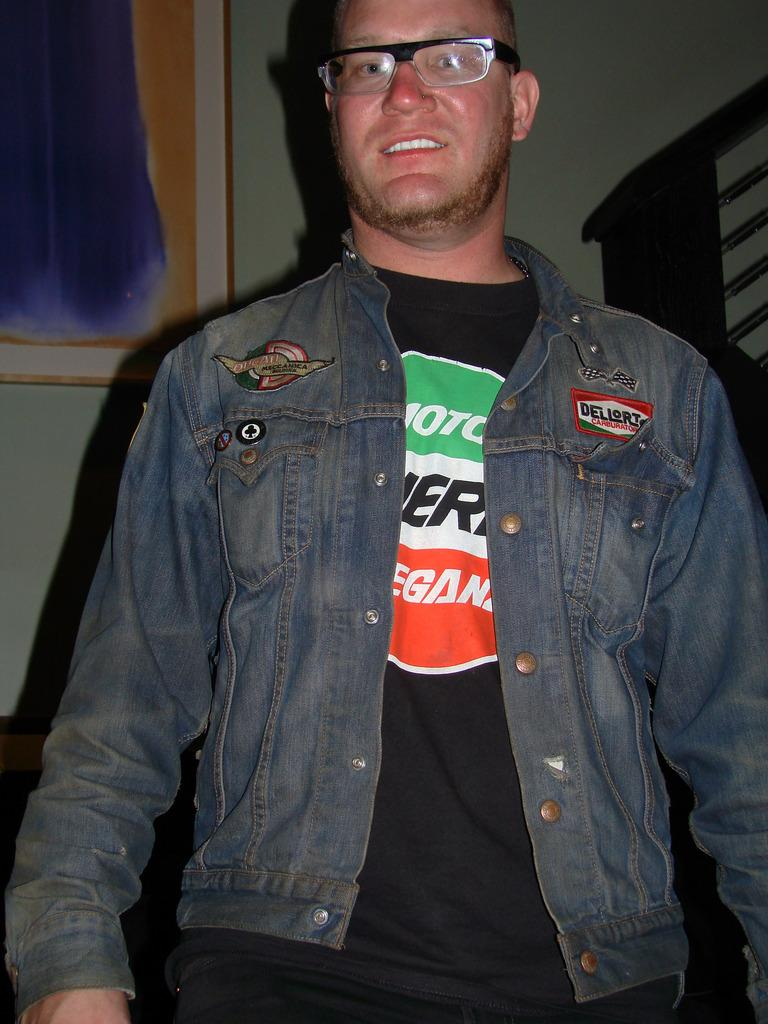Who is present in the image? There is a man in the image. What is the man doing in the image? The man is standing in the image. What accessories is the man wearing in the image? The man is wearing glasses (specs) and a jacket in the image. What can be seen on the wall in the background of the image? There is a photo frame on the wall in the background of the image. What type of punishment is the man receiving in the image? There is no indication of punishment in the image; the man is simply standing and wearing glasses and a jacket. 